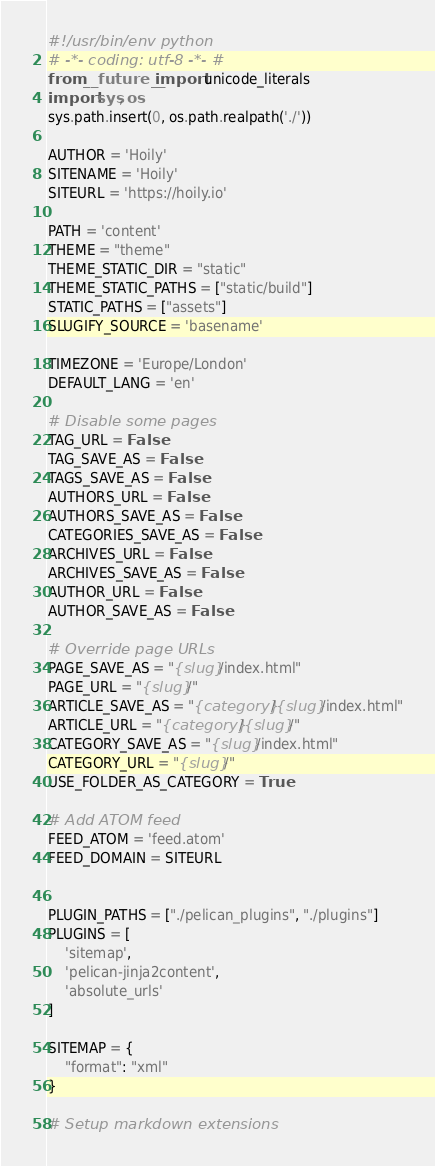<code> <loc_0><loc_0><loc_500><loc_500><_Python_>#!/usr/bin/env python
# -*- coding: utf-8 -*- #
from __future__ import unicode_literals
import sys, os
sys.path.insert(0, os.path.realpath('./'))

AUTHOR = 'Hoily'
SITENAME = 'Hoily'
SITEURL = 'https://hoily.io'

PATH = 'content'
THEME = "theme"
THEME_STATIC_DIR = "static"
THEME_STATIC_PATHS = ["static/build"]
STATIC_PATHS = ["assets"]
SLUGIFY_SOURCE = 'basename'

TIMEZONE = 'Europe/London'
DEFAULT_LANG = 'en'

# Disable some pages
TAG_URL = False
TAG_SAVE_AS = False
TAGS_SAVE_AS = False
AUTHORS_URL = False
AUTHORS_SAVE_AS = False
CATEGORIES_SAVE_AS = False
ARCHIVES_URL = False
ARCHIVES_SAVE_AS = False
AUTHOR_URL = False
AUTHOR_SAVE_AS = False

# Override page URLs
PAGE_SAVE_AS = "{slug}/index.html"
PAGE_URL = "{slug}/"
ARTICLE_SAVE_AS = "{category}/{slug}/index.html"
ARTICLE_URL = "{category}/{slug}/"
CATEGORY_SAVE_AS = "{slug}/index.html"
CATEGORY_URL = "{slug}/"
USE_FOLDER_AS_CATEGORY = True

# Add ATOM feed
FEED_ATOM = 'feed.atom'
FEED_DOMAIN = SITEURL


PLUGIN_PATHS = ["./pelican_plugins", "./plugins"]
PLUGINS = [
    'sitemap',
    'pelican-jinja2content',
    'absolute_urls'
]

SITEMAP = {
    "format": "xml"
}

# Setup markdown extensions</code> 